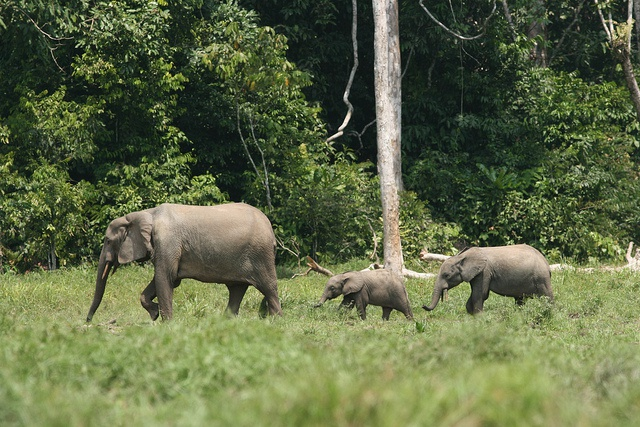Describe the objects in this image and their specific colors. I can see elephant in olive, gray, black, and darkgreen tones, elephant in olive, black, gray, and darkgray tones, and elephant in olive, gray, black, and tan tones in this image. 